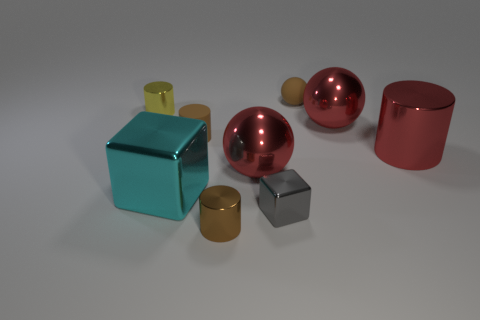Are there any purple things made of the same material as the yellow thing?
Offer a terse response. No. What is the material of the brown sphere that is the same size as the yellow metal cylinder?
Give a very brief answer. Rubber. There is a red ball behind the brown rubber thing left of the shiny cylinder that is in front of the cyan thing; what is its size?
Ensure brevity in your answer.  Large. There is a ball that is left of the small sphere; are there any objects behind it?
Ensure brevity in your answer.  Yes. There is a small gray thing; does it have the same shape as the large cyan metallic object to the left of the tiny cube?
Provide a short and direct response. Yes. The small rubber thing left of the small sphere is what color?
Offer a terse response. Brown. There is a brown rubber thing that is in front of the small brown matte thing that is on the right side of the small matte cylinder; what size is it?
Keep it short and to the point. Small. Is the shape of the tiny metal object left of the small brown matte cylinder the same as  the tiny brown metallic object?
Keep it short and to the point. Yes. There is another small brown thing that is the same shape as the brown shiny object; what material is it?
Your answer should be very brief. Rubber. How many objects are either small cylinders that are right of the small yellow metallic thing or tiny brown matte things that are behind the tiny brown matte cylinder?
Your answer should be compact. 3. 